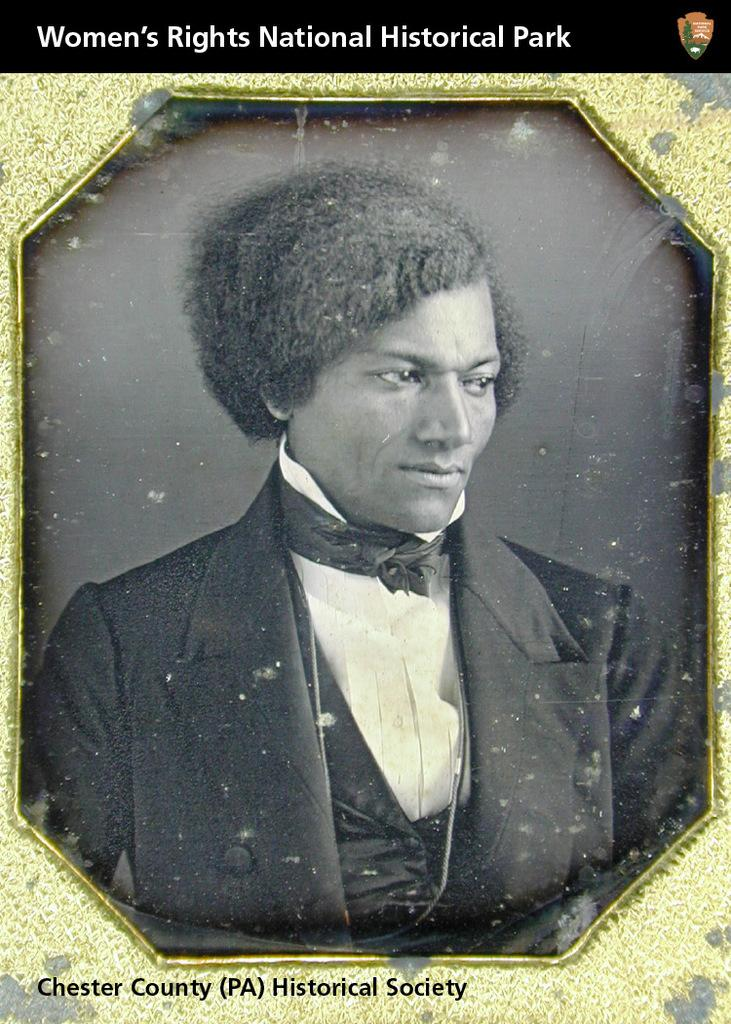<image>
Provide a brief description of the given image. The line under the photograph is about the Chester County Historical Society. 